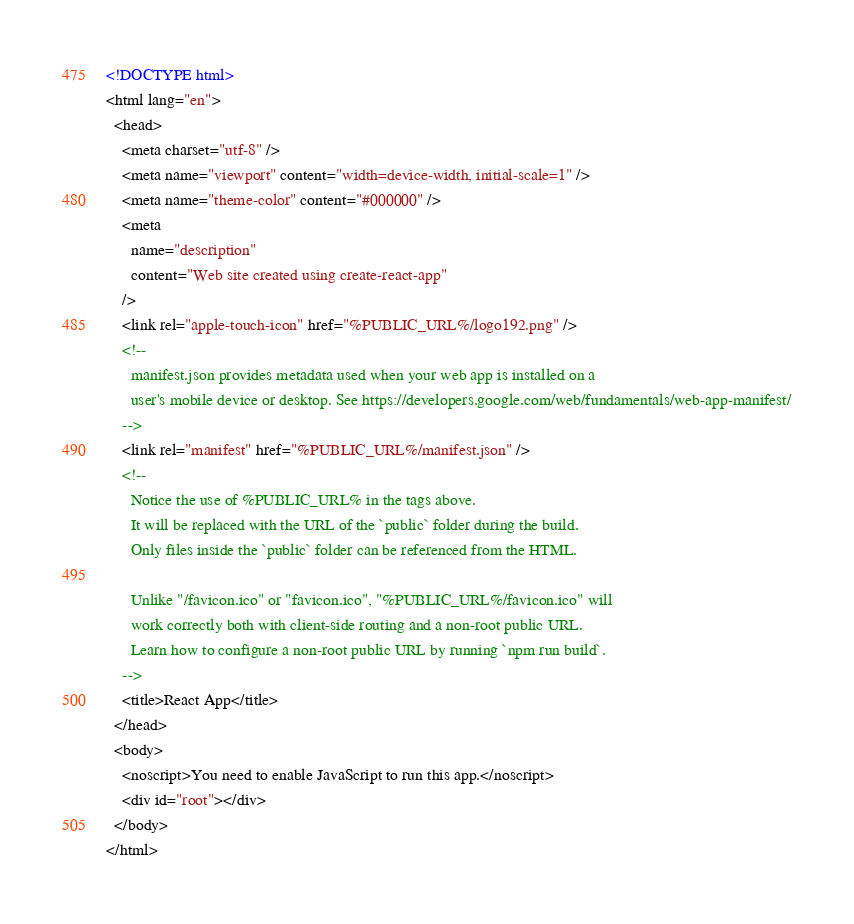<code> <loc_0><loc_0><loc_500><loc_500><_HTML_><!DOCTYPE html>
<html lang="en">
  <head>
    <meta charset="utf-8" />
    <meta name="viewport" content="width=device-width, initial-scale=1" />
    <meta name="theme-color" content="#000000" />
    <meta
      name="description"
      content="Web site created using create-react-app"
    />
    <link rel="apple-touch-icon" href="%PUBLIC_URL%/logo192.png" />
    <!--
      manifest.json provides metadata used when your web app is installed on a
      user's mobile device or desktop. See https://developers.google.com/web/fundamentals/web-app-manifest/
    -->
    <link rel="manifest" href="%PUBLIC_URL%/manifest.json" />
    <!--
      Notice the use of %PUBLIC_URL% in the tags above.
      It will be replaced with the URL of the `public` folder during the build.
      Only files inside the `public` folder can be referenced from the HTML.

      Unlike "/favicon.ico" or "favicon.ico", "%PUBLIC_URL%/favicon.ico" will
      work correctly both with client-side routing and a non-root public URL.
      Learn how to configure a non-root public URL by running `npm run build`.
    -->
    <title>React App</title>
  </head>
  <body>
    <noscript>You need to enable JavaScript to run this app.</noscript>
    <div id="root"></div>
  </body>
</html>
</code> 